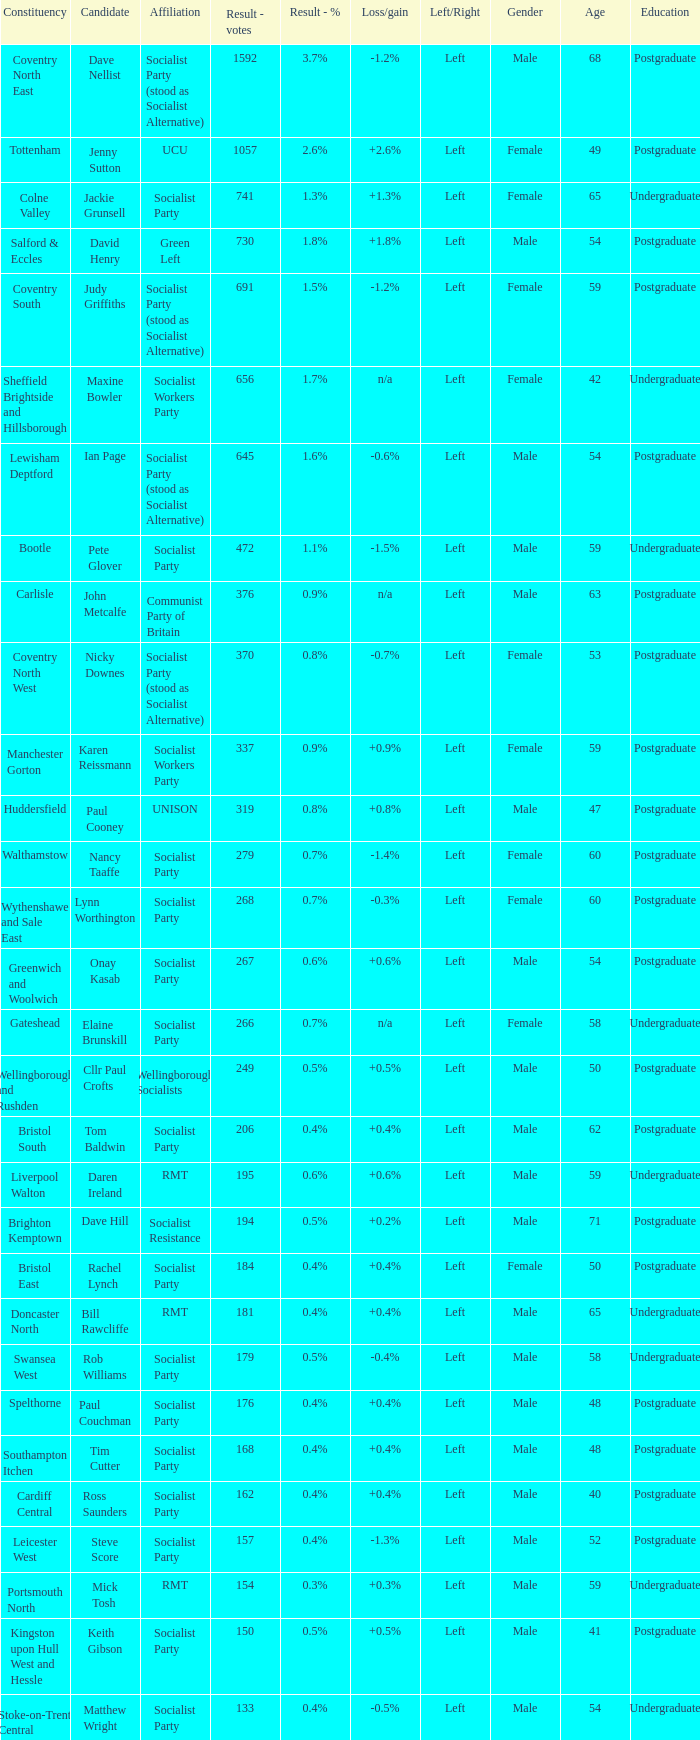What is every affiliation for candidate Daren Ireland? RMT. 